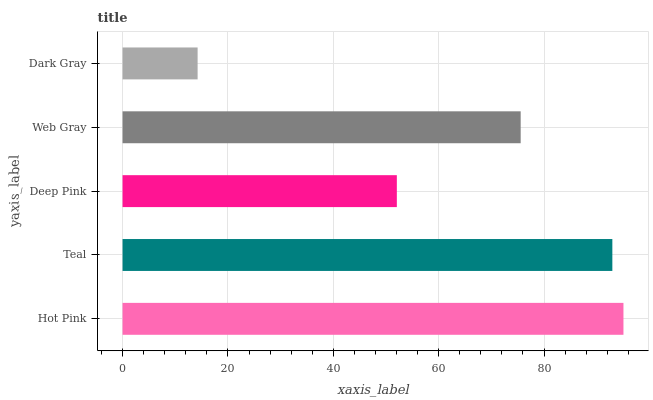Is Dark Gray the minimum?
Answer yes or no. Yes. Is Hot Pink the maximum?
Answer yes or no. Yes. Is Teal the minimum?
Answer yes or no. No. Is Teal the maximum?
Answer yes or no. No. Is Hot Pink greater than Teal?
Answer yes or no. Yes. Is Teal less than Hot Pink?
Answer yes or no. Yes. Is Teal greater than Hot Pink?
Answer yes or no. No. Is Hot Pink less than Teal?
Answer yes or no. No. Is Web Gray the high median?
Answer yes or no. Yes. Is Web Gray the low median?
Answer yes or no. Yes. Is Hot Pink the high median?
Answer yes or no. No. Is Hot Pink the low median?
Answer yes or no. No. 